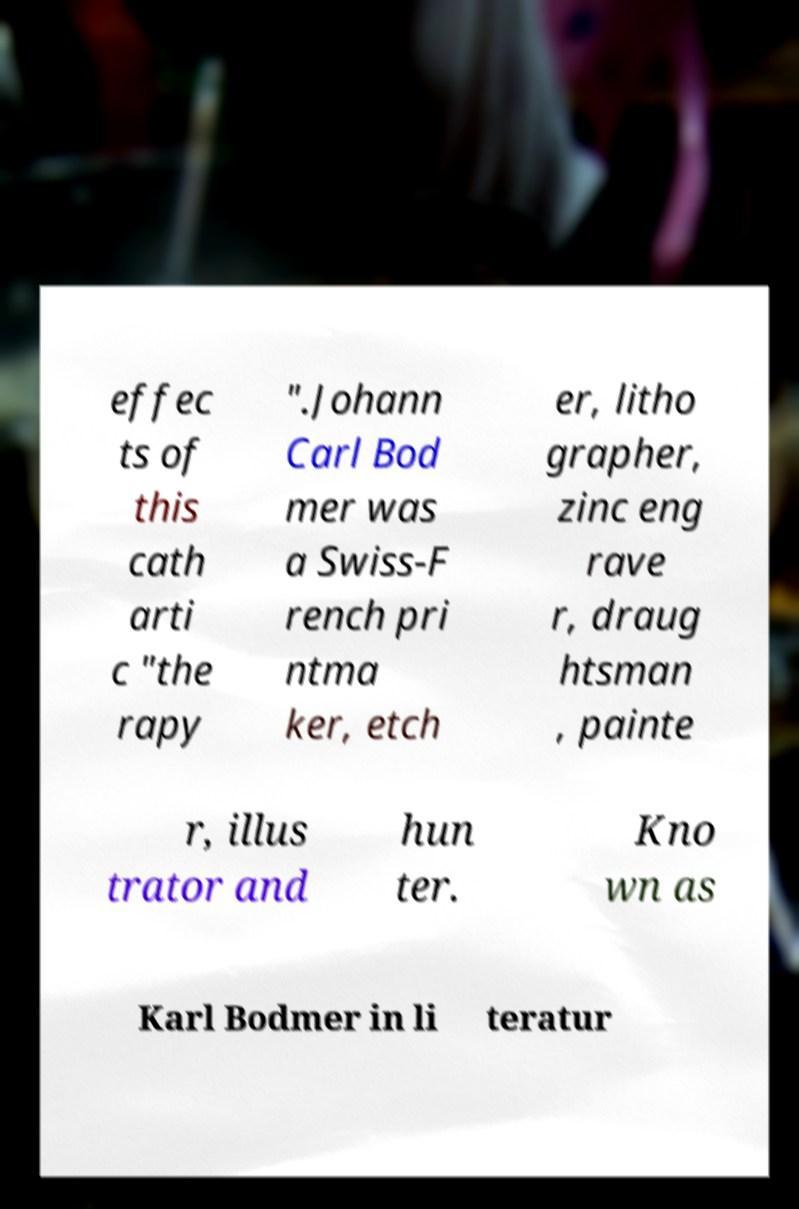Please read and relay the text visible in this image. What does it say? effec ts of this cath arti c "the rapy ".Johann Carl Bod mer was a Swiss-F rench pri ntma ker, etch er, litho grapher, zinc eng rave r, draug htsman , painte r, illus trator and hun ter. Kno wn as Karl Bodmer in li teratur 